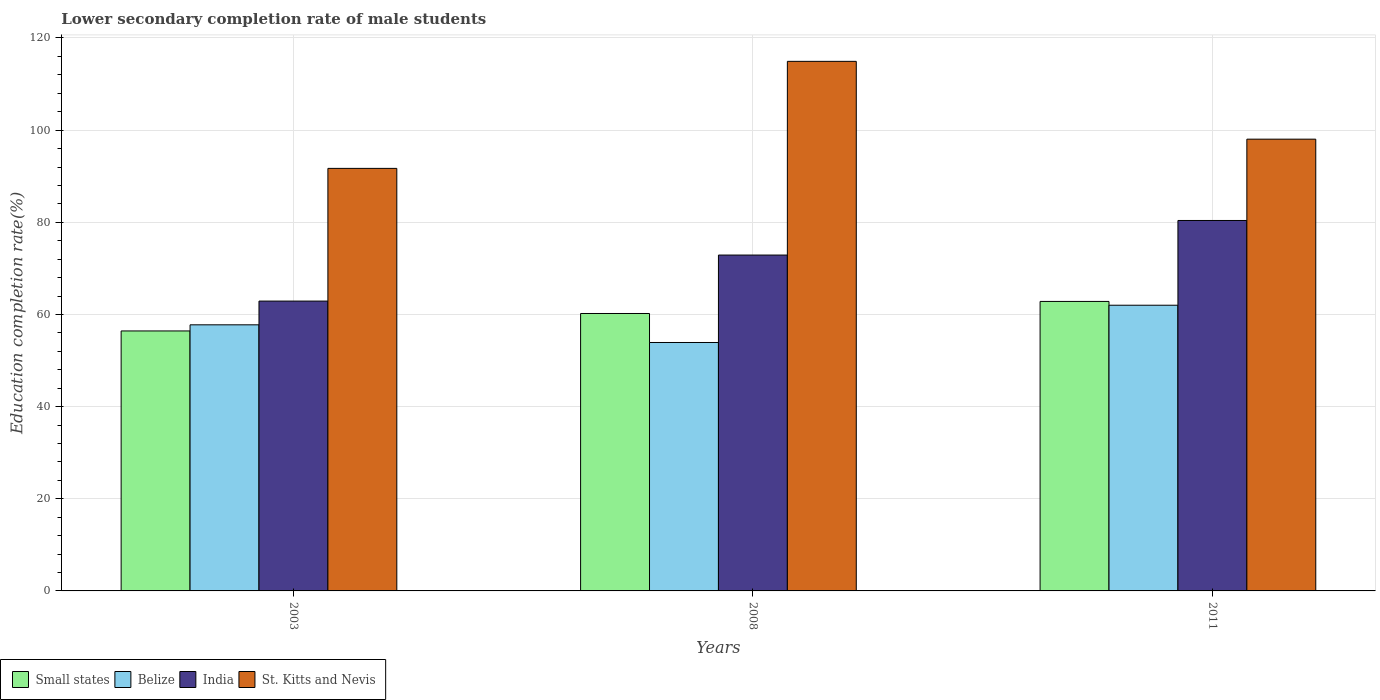How many bars are there on the 1st tick from the right?
Make the answer very short. 4. In how many cases, is the number of bars for a given year not equal to the number of legend labels?
Make the answer very short. 0. What is the lower secondary completion rate of male students in India in 2008?
Offer a terse response. 72.89. Across all years, what is the maximum lower secondary completion rate of male students in Belize?
Give a very brief answer. 62. Across all years, what is the minimum lower secondary completion rate of male students in India?
Provide a short and direct response. 62.9. In which year was the lower secondary completion rate of male students in Small states maximum?
Your response must be concise. 2011. What is the total lower secondary completion rate of male students in Small states in the graph?
Offer a terse response. 179.46. What is the difference between the lower secondary completion rate of male students in Small states in 2008 and that in 2011?
Make the answer very short. -2.62. What is the difference between the lower secondary completion rate of male students in St. Kitts and Nevis in 2011 and the lower secondary completion rate of male students in India in 2008?
Offer a terse response. 25.15. What is the average lower secondary completion rate of male students in Belize per year?
Provide a succinct answer. 57.89. In the year 2003, what is the difference between the lower secondary completion rate of male students in Belize and lower secondary completion rate of male students in St. Kitts and Nevis?
Your answer should be very brief. -33.95. In how many years, is the lower secondary completion rate of male students in Belize greater than 64 %?
Your response must be concise. 0. What is the ratio of the lower secondary completion rate of male students in St. Kitts and Nevis in 2003 to that in 2011?
Offer a terse response. 0.94. What is the difference between the highest and the second highest lower secondary completion rate of male students in St. Kitts and Nevis?
Keep it short and to the point. 16.89. What is the difference between the highest and the lowest lower secondary completion rate of male students in Small states?
Your answer should be very brief. 6.41. In how many years, is the lower secondary completion rate of male students in Belize greater than the average lower secondary completion rate of male students in Belize taken over all years?
Provide a short and direct response. 1. Is it the case that in every year, the sum of the lower secondary completion rate of male students in Belize and lower secondary completion rate of male students in St. Kitts and Nevis is greater than the sum of lower secondary completion rate of male students in India and lower secondary completion rate of male students in Small states?
Keep it short and to the point. No. What does the 2nd bar from the left in 2011 represents?
Your answer should be compact. Belize. Does the graph contain grids?
Offer a terse response. Yes. Where does the legend appear in the graph?
Offer a very short reply. Bottom left. How many legend labels are there?
Ensure brevity in your answer.  4. What is the title of the graph?
Make the answer very short. Lower secondary completion rate of male students. Does "Mauritania" appear as one of the legend labels in the graph?
Offer a very short reply. No. What is the label or title of the Y-axis?
Give a very brief answer. Education completion rate(%). What is the Education completion rate(%) in Small states in 2003?
Your answer should be very brief. 56.42. What is the Education completion rate(%) in Belize in 2003?
Your answer should be very brief. 57.75. What is the Education completion rate(%) in India in 2003?
Your answer should be compact. 62.9. What is the Education completion rate(%) of St. Kitts and Nevis in 2003?
Your answer should be very brief. 91.7. What is the Education completion rate(%) of Small states in 2008?
Provide a short and direct response. 60.21. What is the Education completion rate(%) in Belize in 2008?
Offer a terse response. 53.91. What is the Education completion rate(%) in India in 2008?
Your answer should be very brief. 72.89. What is the Education completion rate(%) in St. Kitts and Nevis in 2008?
Offer a very short reply. 114.93. What is the Education completion rate(%) of Small states in 2011?
Provide a short and direct response. 62.83. What is the Education completion rate(%) in Belize in 2011?
Offer a terse response. 62. What is the Education completion rate(%) in India in 2011?
Provide a short and direct response. 80.39. What is the Education completion rate(%) in St. Kitts and Nevis in 2011?
Provide a succinct answer. 98.04. Across all years, what is the maximum Education completion rate(%) in Small states?
Provide a short and direct response. 62.83. Across all years, what is the maximum Education completion rate(%) in Belize?
Offer a very short reply. 62. Across all years, what is the maximum Education completion rate(%) in India?
Offer a very short reply. 80.39. Across all years, what is the maximum Education completion rate(%) in St. Kitts and Nevis?
Your response must be concise. 114.93. Across all years, what is the minimum Education completion rate(%) in Small states?
Your answer should be very brief. 56.42. Across all years, what is the minimum Education completion rate(%) in Belize?
Offer a terse response. 53.91. Across all years, what is the minimum Education completion rate(%) in India?
Your response must be concise. 62.9. Across all years, what is the minimum Education completion rate(%) of St. Kitts and Nevis?
Offer a very short reply. 91.7. What is the total Education completion rate(%) of Small states in the graph?
Provide a short and direct response. 179.46. What is the total Education completion rate(%) of Belize in the graph?
Make the answer very short. 173.67. What is the total Education completion rate(%) in India in the graph?
Provide a succinct answer. 216.19. What is the total Education completion rate(%) in St. Kitts and Nevis in the graph?
Provide a succinct answer. 304.67. What is the difference between the Education completion rate(%) in Small states in 2003 and that in 2008?
Provide a short and direct response. -3.79. What is the difference between the Education completion rate(%) in Belize in 2003 and that in 2008?
Make the answer very short. 3.83. What is the difference between the Education completion rate(%) in India in 2003 and that in 2008?
Your answer should be compact. -9.99. What is the difference between the Education completion rate(%) of St. Kitts and Nevis in 2003 and that in 2008?
Your answer should be compact. -23.23. What is the difference between the Education completion rate(%) of Small states in 2003 and that in 2011?
Provide a short and direct response. -6.41. What is the difference between the Education completion rate(%) of Belize in 2003 and that in 2011?
Provide a succinct answer. -4.25. What is the difference between the Education completion rate(%) of India in 2003 and that in 2011?
Keep it short and to the point. -17.49. What is the difference between the Education completion rate(%) of St. Kitts and Nevis in 2003 and that in 2011?
Offer a very short reply. -6.34. What is the difference between the Education completion rate(%) of Small states in 2008 and that in 2011?
Offer a very short reply. -2.62. What is the difference between the Education completion rate(%) in Belize in 2008 and that in 2011?
Provide a short and direct response. -8.09. What is the difference between the Education completion rate(%) of India in 2008 and that in 2011?
Keep it short and to the point. -7.5. What is the difference between the Education completion rate(%) of St. Kitts and Nevis in 2008 and that in 2011?
Your answer should be very brief. 16.89. What is the difference between the Education completion rate(%) of Small states in 2003 and the Education completion rate(%) of Belize in 2008?
Your answer should be very brief. 2.51. What is the difference between the Education completion rate(%) in Small states in 2003 and the Education completion rate(%) in India in 2008?
Offer a terse response. -16.47. What is the difference between the Education completion rate(%) of Small states in 2003 and the Education completion rate(%) of St. Kitts and Nevis in 2008?
Make the answer very short. -58.51. What is the difference between the Education completion rate(%) in Belize in 2003 and the Education completion rate(%) in India in 2008?
Your answer should be very brief. -15.14. What is the difference between the Education completion rate(%) in Belize in 2003 and the Education completion rate(%) in St. Kitts and Nevis in 2008?
Offer a very short reply. -57.18. What is the difference between the Education completion rate(%) in India in 2003 and the Education completion rate(%) in St. Kitts and Nevis in 2008?
Offer a terse response. -52.03. What is the difference between the Education completion rate(%) in Small states in 2003 and the Education completion rate(%) in Belize in 2011?
Keep it short and to the point. -5.58. What is the difference between the Education completion rate(%) in Small states in 2003 and the Education completion rate(%) in India in 2011?
Your answer should be very brief. -23.97. What is the difference between the Education completion rate(%) of Small states in 2003 and the Education completion rate(%) of St. Kitts and Nevis in 2011?
Give a very brief answer. -41.62. What is the difference between the Education completion rate(%) in Belize in 2003 and the Education completion rate(%) in India in 2011?
Give a very brief answer. -22.65. What is the difference between the Education completion rate(%) in Belize in 2003 and the Education completion rate(%) in St. Kitts and Nevis in 2011?
Provide a short and direct response. -40.29. What is the difference between the Education completion rate(%) of India in 2003 and the Education completion rate(%) of St. Kitts and Nevis in 2011?
Provide a short and direct response. -35.14. What is the difference between the Education completion rate(%) in Small states in 2008 and the Education completion rate(%) in Belize in 2011?
Provide a succinct answer. -1.79. What is the difference between the Education completion rate(%) of Small states in 2008 and the Education completion rate(%) of India in 2011?
Ensure brevity in your answer.  -20.18. What is the difference between the Education completion rate(%) in Small states in 2008 and the Education completion rate(%) in St. Kitts and Nevis in 2011?
Keep it short and to the point. -37.83. What is the difference between the Education completion rate(%) of Belize in 2008 and the Education completion rate(%) of India in 2011?
Offer a terse response. -26.48. What is the difference between the Education completion rate(%) of Belize in 2008 and the Education completion rate(%) of St. Kitts and Nevis in 2011?
Your response must be concise. -44.13. What is the difference between the Education completion rate(%) of India in 2008 and the Education completion rate(%) of St. Kitts and Nevis in 2011?
Offer a very short reply. -25.15. What is the average Education completion rate(%) in Small states per year?
Give a very brief answer. 59.82. What is the average Education completion rate(%) of Belize per year?
Offer a very short reply. 57.89. What is the average Education completion rate(%) in India per year?
Offer a terse response. 72.06. What is the average Education completion rate(%) of St. Kitts and Nevis per year?
Provide a succinct answer. 101.56. In the year 2003, what is the difference between the Education completion rate(%) in Small states and Education completion rate(%) in Belize?
Keep it short and to the point. -1.33. In the year 2003, what is the difference between the Education completion rate(%) of Small states and Education completion rate(%) of India?
Keep it short and to the point. -6.48. In the year 2003, what is the difference between the Education completion rate(%) in Small states and Education completion rate(%) in St. Kitts and Nevis?
Offer a very short reply. -35.28. In the year 2003, what is the difference between the Education completion rate(%) in Belize and Education completion rate(%) in India?
Offer a very short reply. -5.15. In the year 2003, what is the difference between the Education completion rate(%) of Belize and Education completion rate(%) of St. Kitts and Nevis?
Provide a succinct answer. -33.95. In the year 2003, what is the difference between the Education completion rate(%) in India and Education completion rate(%) in St. Kitts and Nevis?
Give a very brief answer. -28.8. In the year 2008, what is the difference between the Education completion rate(%) in Small states and Education completion rate(%) in Belize?
Provide a short and direct response. 6.3. In the year 2008, what is the difference between the Education completion rate(%) of Small states and Education completion rate(%) of India?
Your answer should be very brief. -12.68. In the year 2008, what is the difference between the Education completion rate(%) of Small states and Education completion rate(%) of St. Kitts and Nevis?
Provide a succinct answer. -54.72. In the year 2008, what is the difference between the Education completion rate(%) of Belize and Education completion rate(%) of India?
Provide a succinct answer. -18.98. In the year 2008, what is the difference between the Education completion rate(%) of Belize and Education completion rate(%) of St. Kitts and Nevis?
Your response must be concise. -61.01. In the year 2008, what is the difference between the Education completion rate(%) of India and Education completion rate(%) of St. Kitts and Nevis?
Your response must be concise. -42.04. In the year 2011, what is the difference between the Education completion rate(%) of Small states and Education completion rate(%) of Belize?
Keep it short and to the point. 0.83. In the year 2011, what is the difference between the Education completion rate(%) in Small states and Education completion rate(%) in India?
Offer a terse response. -17.57. In the year 2011, what is the difference between the Education completion rate(%) in Small states and Education completion rate(%) in St. Kitts and Nevis?
Your answer should be compact. -35.22. In the year 2011, what is the difference between the Education completion rate(%) in Belize and Education completion rate(%) in India?
Keep it short and to the point. -18.39. In the year 2011, what is the difference between the Education completion rate(%) of Belize and Education completion rate(%) of St. Kitts and Nevis?
Make the answer very short. -36.04. In the year 2011, what is the difference between the Education completion rate(%) of India and Education completion rate(%) of St. Kitts and Nevis?
Offer a terse response. -17.65. What is the ratio of the Education completion rate(%) of Small states in 2003 to that in 2008?
Give a very brief answer. 0.94. What is the ratio of the Education completion rate(%) in Belize in 2003 to that in 2008?
Your response must be concise. 1.07. What is the ratio of the Education completion rate(%) of India in 2003 to that in 2008?
Make the answer very short. 0.86. What is the ratio of the Education completion rate(%) in St. Kitts and Nevis in 2003 to that in 2008?
Your answer should be compact. 0.8. What is the ratio of the Education completion rate(%) of Small states in 2003 to that in 2011?
Your answer should be very brief. 0.9. What is the ratio of the Education completion rate(%) in Belize in 2003 to that in 2011?
Your answer should be very brief. 0.93. What is the ratio of the Education completion rate(%) in India in 2003 to that in 2011?
Your response must be concise. 0.78. What is the ratio of the Education completion rate(%) of St. Kitts and Nevis in 2003 to that in 2011?
Your response must be concise. 0.94. What is the ratio of the Education completion rate(%) in Small states in 2008 to that in 2011?
Your response must be concise. 0.96. What is the ratio of the Education completion rate(%) of Belize in 2008 to that in 2011?
Make the answer very short. 0.87. What is the ratio of the Education completion rate(%) of India in 2008 to that in 2011?
Your answer should be very brief. 0.91. What is the ratio of the Education completion rate(%) of St. Kitts and Nevis in 2008 to that in 2011?
Provide a short and direct response. 1.17. What is the difference between the highest and the second highest Education completion rate(%) of Small states?
Give a very brief answer. 2.62. What is the difference between the highest and the second highest Education completion rate(%) of Belize?
Provide a succinct answer. 4.25. What is the difference between the highest and the second highest Education completion rate(%) of India?
Ensure brevity in your answer.  7.5. What is the difference between the highest and the second highest Education completion rate(%) in St. Kitts and Nevis?
Your answer should be very brief. 16.89. What is the difference between the highest and the lowest Education completion rate(%) of Small states?
Your response must be concise. 6.41. What is the difference between the highest and the lowest Education completion rate(%) of Belize?
Provide a short and direct response. 8.09. What is the difference between the highest and the lowest Education completion rate(%) in India?
Ensure brevity in your answer.  17.49. What is the difference between the highest and the lowest Education completion rate(%) of St. Kitts and Nevis?
Offer a very short reply. 23.23. 